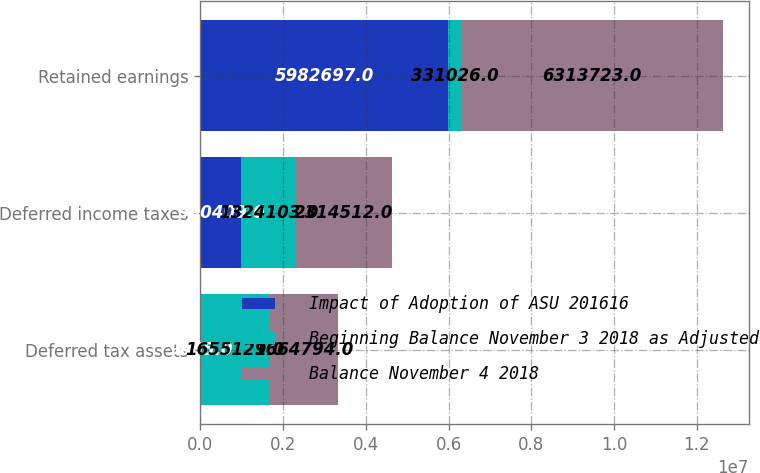Convert chart to OTSL. <chart><loc_0><loc_0><loc_500><loc_500><stacked_bar_chart><ecel><fcel>Deferred tax assets<fcel>Deferred income taxes<fcel>Retained earnings<nl><fcel>Impact of Adoption of ASU 201616<fcel>9665<fcel>990409<fcel>5.9827e+06<nl><fcel>Beginning Balance November 3 2018 as Adjusted<fcel>1.65513e+06<fcel>1.3241e+06<fcel>331026<nl><fcel>Balance November 4 2018<fcel>1.66479e+06<fcel>2.31451e+06<fcel>6.31372e+06<nl></chart> 